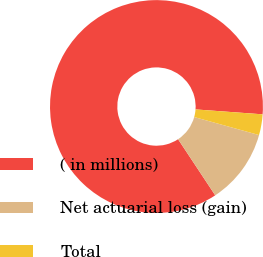<chart> <loc_0><loc_0><loc_500><loc_500><pie_chart><fcel>( in millions)<fcel>Net actuarial loss (gain)<fcel>Total<nl><fcel>85.47%<fcel>11.38%<fcel>3.15%<nl></chart> 